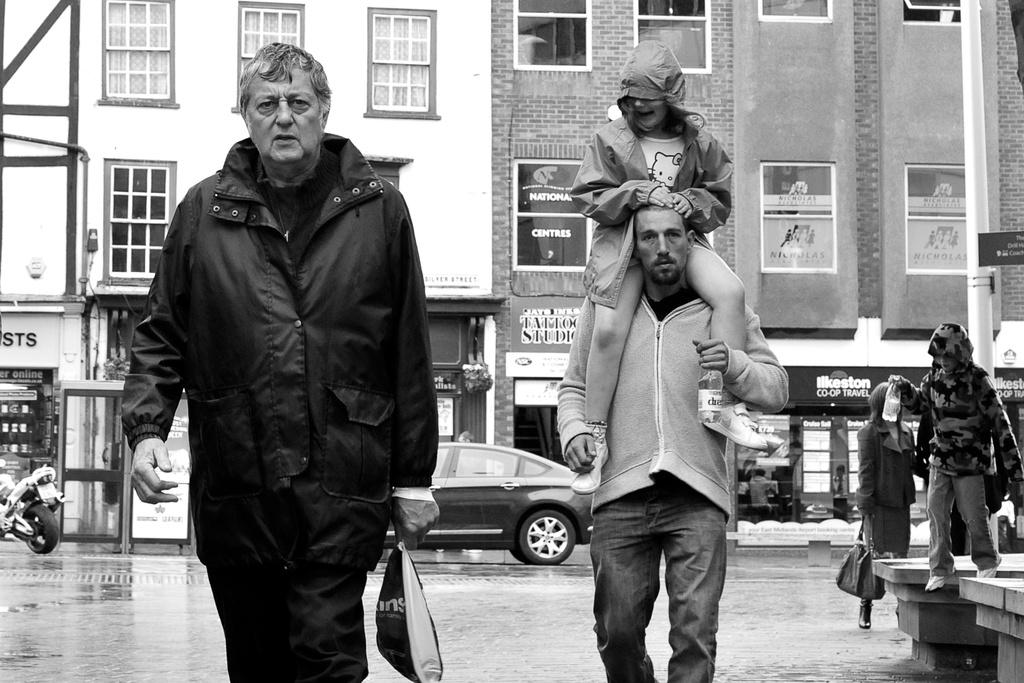What is happening with the group of people in the image? There is a person sitting on another person in the image. What else can be seen in the image besides the group of people? There are vehicles on the road and buildings visible in the image. Can you describe any other objects or structures in the image? There is a pole in the image. How many frogs are sitting on the banana in the image? There are no frogs or bananas present in the image. What type of wire can be seen connecting the buildings in the image? There is no wire connecting the buildings in the image. 